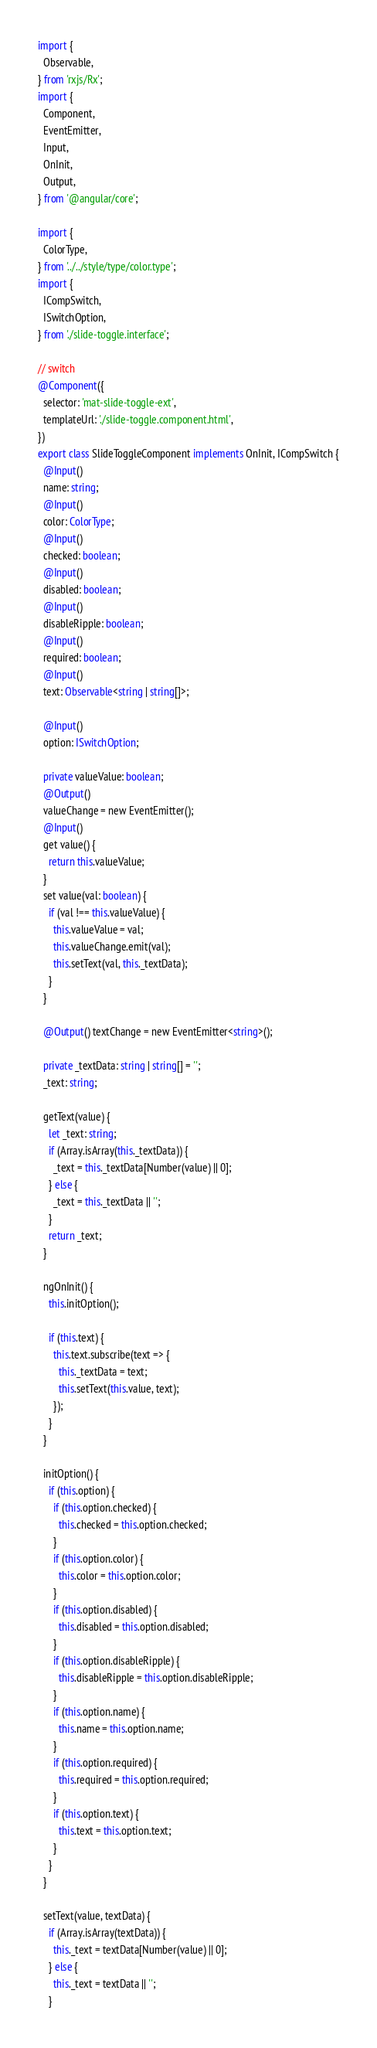Convert code to text. <code><loc_0><loc_0><loc_500><loc_500><_TypeScript_>import {
  Observable,
} from 'rxjs/Rx';
import {
  Component,
  EventEmitter,
  Input,
  OnInit,
  Output,
} from '@angular/core';

import {
  ColorType,
} from '../../style/type/color.type';
import {
  ICompSwitch,
  ISwitchOption,
} from './slide-toggle.interface';

// switch
@Component({
  selector: 'mat-slide-toggle-ext',
  templateUrl: './slide-toggle.component.html',
})
export class SlideToggleComponent implements OnInit, ICompSwitch {
  @Input()
  name: string;
  @Input()
  color: ColorType;
  @Input()
  checked: boolean;
  @Input()
  disabled: boolean;
  @Input()
  disableRipple: boolean;
  @Input()
  required: boolean;
  @Input()
  text: Observable<string | string[]>;

  @Input()
  option: ISwitchOption;

  private valueValue: boolean;
  @Output()
  valueChange = new EventEmitter();
  @Input()
  get value() {
    return this.valueValue;
  }
  set value(val: boolean) {
    if (val !== this.valueValue) {
      this.valueValue = val;
      this.valueChange.emit(val);
      this.setText(val, this._textData);
    }
  }

  @Output() textChange = new EventEmitter<string>();

  private _textData: string | string[] = '';
  _text: string;

  getText(value) {
    let _text: string;
    if (Array.isArray(this._textData)) {
      _text = this._textData[Number(value) || 0];
    } else {
      _text = this._textData || '';
    }
    return _text;
  }

  ngOnInit() {
    this.initOption();

    if (this.text) {
      this.text.subscribe(text => {
        this._textData = text;
        this.setText(this.value, text);
      });
    }
  }

  initOption() {
    if (this.option) {
      if (this.option.checked) {
        this.checked = this.option.checked;
      }
      if (this.option.color) {
        this.color = this.option.color;
      }
      if (this.option.disabled) {
        this.disabled = this.option.disabled;
      }
      if (this.option.disableRipple) {
        this.disableRipple = this.option.disableRipple;
      }
      if (this.option.name) {
        this.name = this.option.name;
      }
      if (this.option.required) {
        this.required = this.option.required;
      }
      if (this.option.text) {
        this.text = this.option.text;
      }
    }
  }

  setText(value, textData) {
    if (Array.isArray(textData)) {
      this._text = textData[Number(value) || 0];
    } else {
      this._text = textData || '';
    }
</code> 